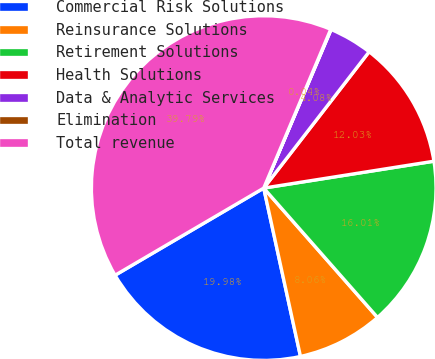<chart> <loc_0><loc_0><loc_500><loc_500><pie_chart><fcel>Commercial Risk Solutions<fcel>Reinsurance Solutions<fcel>Retirement Solutions<fcel>Health Solutions<fcel>Data & Analytic Services<fcel>Elimination<fcel>Total revenue<nl><fcel>19.98%<fcel>8.06%<fcel>16.01%<fcel>12.03%<fcel>4.08%<fcel>0.04%<fcel>39.79%<nl></chart> 